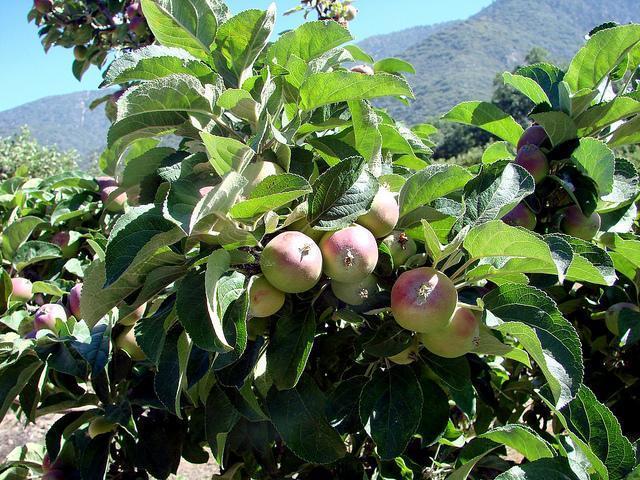How many apples are visible?
Give a very brief answer. 3. How many people are there?
Give a very brief answer. 0. 